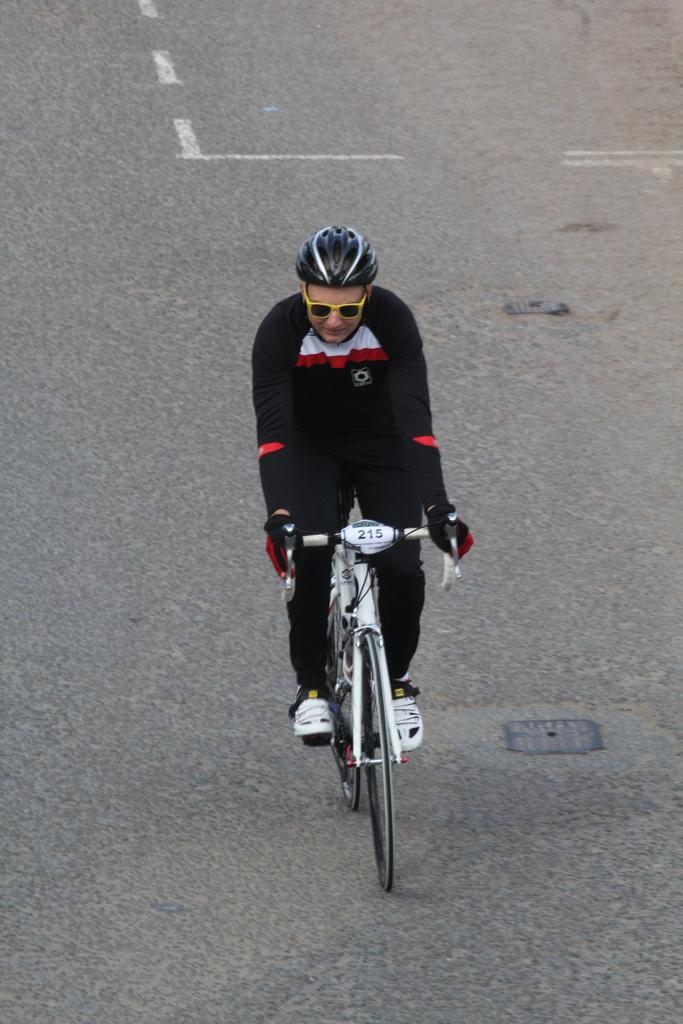Who is present in the image? There is a person in the image. What protective gear is the person wearing? The person is wearing a helmet. What type of eyewear is the person wearing? The person is wearing spectacles. What mode of transportation is the person using? The person is riding a bicycle. Where is the bicycle located? The bicycle is on the road. What type of clouds can be seen in the image? There are no clouds visible in the image; it features a person riding a bicycle on the road. 